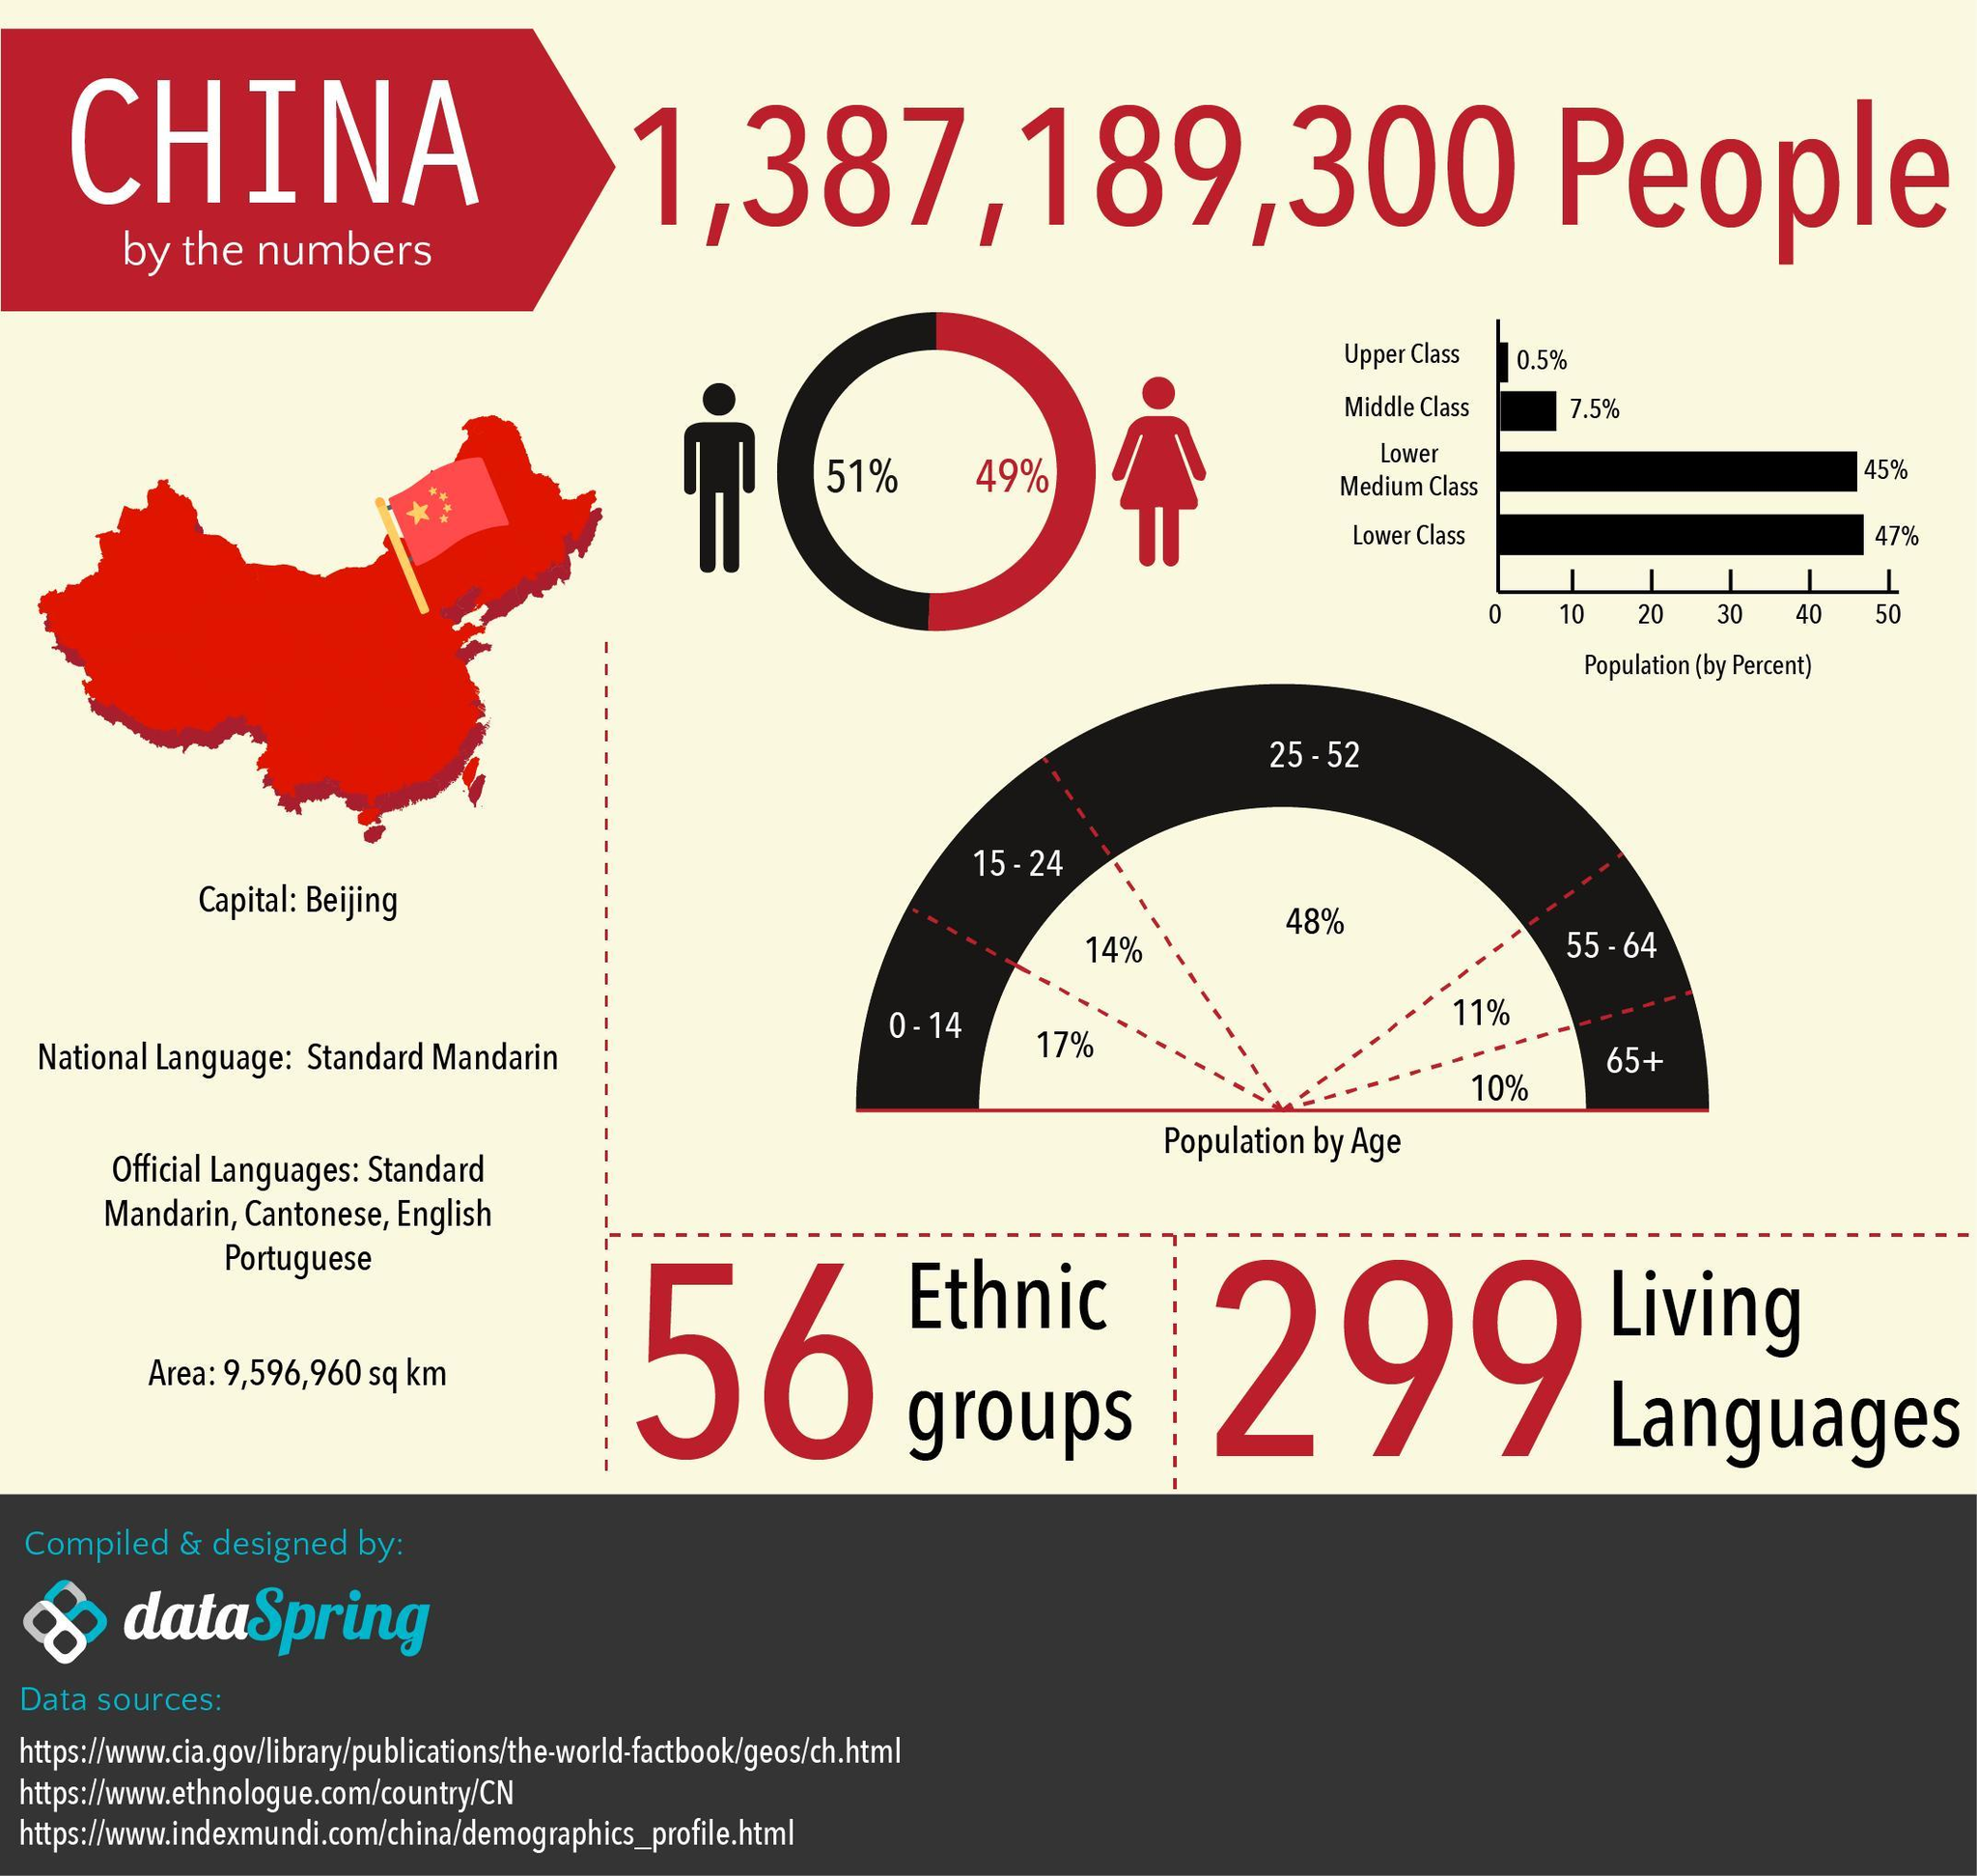How many official languages in China?
Answer the question with a short phrase. 4 What is the percentage of the population whose age group is 0-14 and 15-24, taken together? 31% What is the percentage of the Upper class and Middle-class people in China, taken together? 8% What is the percentage of males in China? 51% What is the percentage of females in China? 49% 